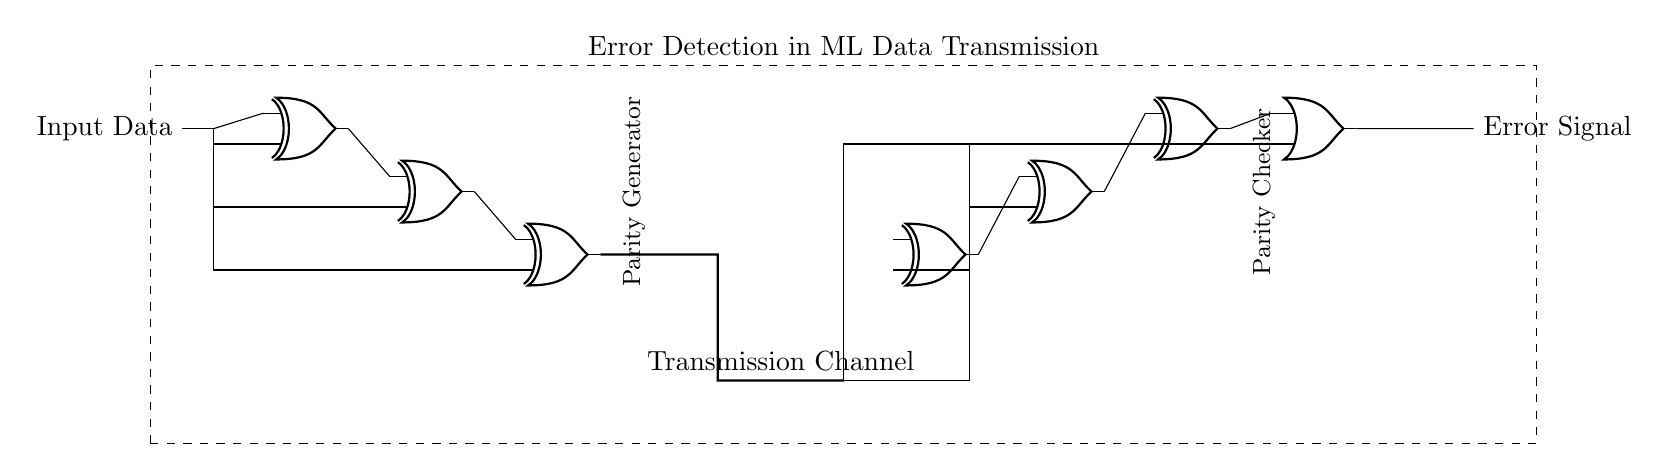What is the main function of this circuit? The circuit's main function is to detect errors in data transmission by generating and checking parity bits through a series of logic gates.
Answer: Error detection How many XOR gates are present in the circuit? Counting the XOR gates in the diagram, there are six indicated within the circuit.
Answer: Six What type of gate is used for the final error detection? The final detection of errors is performed using an OR gate, as shown in the circuit diagram.
Answer: OR gate What is the role of the parity generator? The parity generator's role is to create parity bits from the input data to help identify errors during transmission.
Answer: Generate parity bits Explain how data travels through the circuit from input to output. Data enters the circuit at the input, goes through the XOR gates for parity generation, traverses the transmission channel, arrives at the receiver side for parity checking, and concludes at the OR gate where error detection occurs.
Answer: Through XOR gates to OR gate What happens if an error is detected in the transmission? If an error is detected, the OR gate outputs a signal indicating an error occurred during data transfer.
Answer: Error signal 